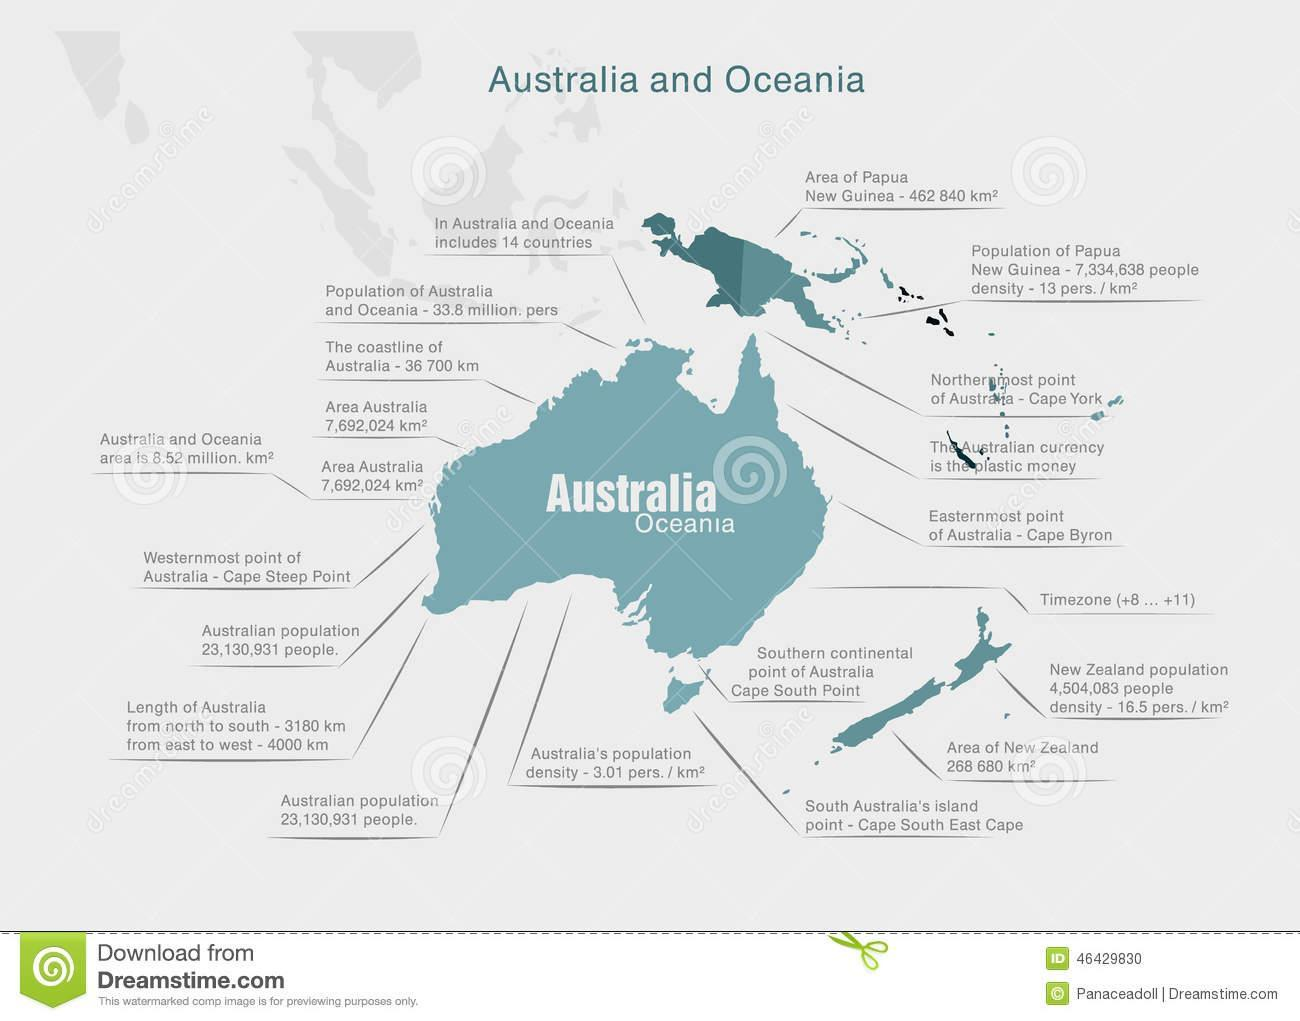What is special about the currency of Australia?
Answer the question with a short phrase. plastic money 